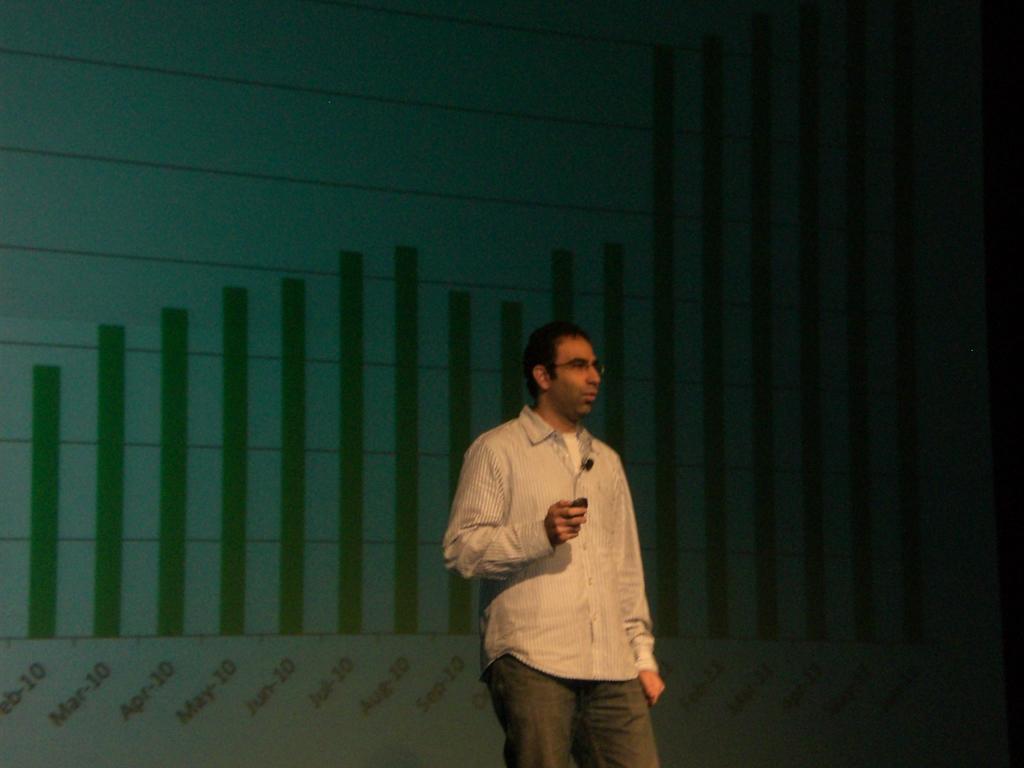Can you describe this image briefly? In this image there is a person standing and holding an object, and at the background there is screen. 